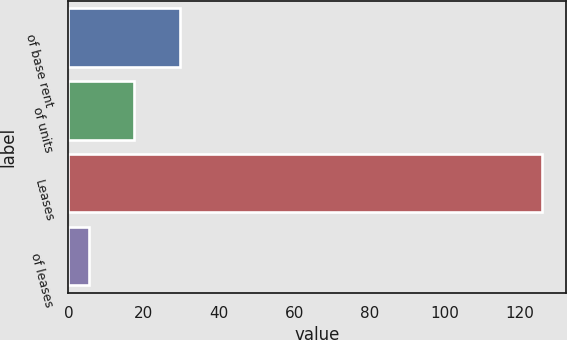<chart> <loc_0><loc_0><loc_500><loc_500><bar_chart><fcel>of base rent<fcel>of units<fcel>Leases<fcel>of leases<nl><fcel>29.6<fcel>17.55<fcel>126<fcel>5.5<nl></chart> 